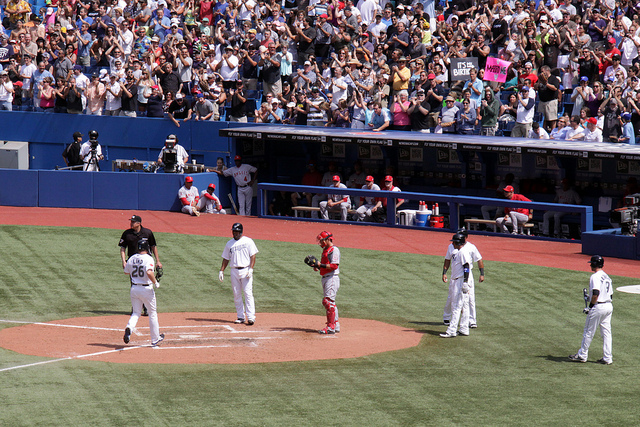Identify and read out the text in this image. 26 9 